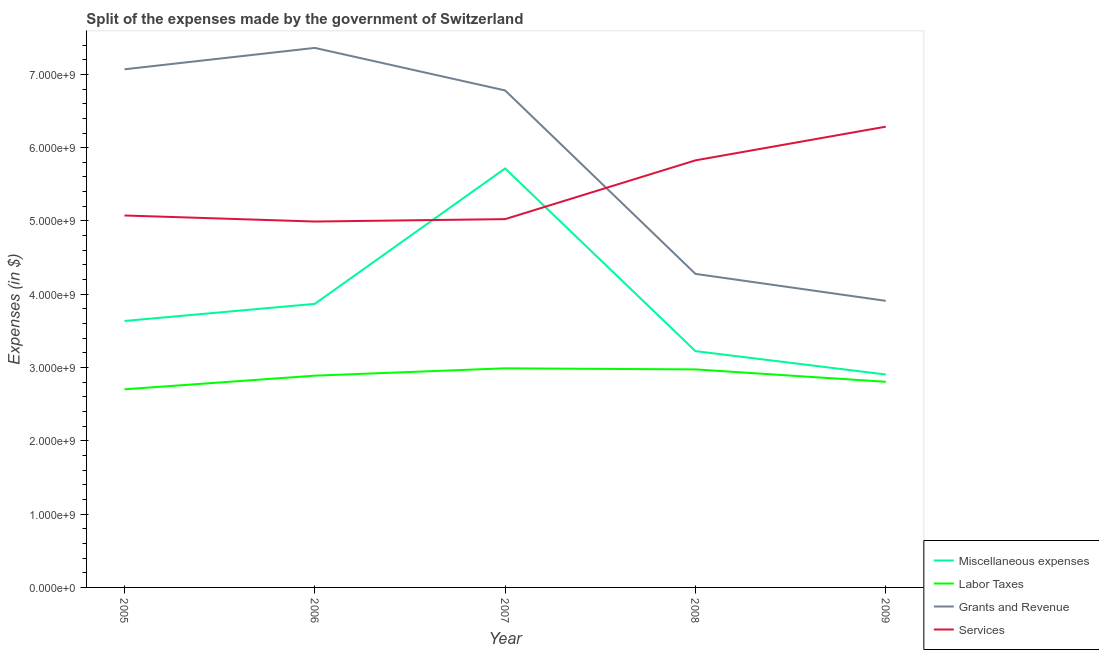Is the number of lines equal to the number of legend labels?
Provide a succinct answer. Yes. What is the amount spent on grants and revenue in 2005?
Provide a succinct answer. 7.07e+09. Across all years, what is the maximum amount spent on grants and revenue?
Your response must be concise. 7.36e+09. Across all years, what is the minimum amount spent on labor taxes?
Your answer should be compact. 2.70e+09. What is the total amount spent on services in the graph?
Provide a short and direct response. 2.72e+1. What is the difference between the amount spent on services in 2005 and that in 2007?
Provide a short and direct response. 4.97e+07. What is the difference between the amount spent on miscellaneous expenses in 2009 and the amount spent on services in 2006?
Ensure brevity in your answer.  -2.09e+09. What is the average amount spent on labor taxes per year?
Your answer should be compact. 2.87e+09. In the year 2006, what is the difference between the amount spent on services and amount spent on miscellaneous expenses?
Your response must be concise. 1.12e+09. In how many years, is the amount spent on miscellaneous expenses greater than 5000000000 $?
Offer a terse response. 1. What is the ratio of the amount spent on labor taxes in 2007 to that in 2009?
Keep it short and to the point. 1.07. Is the amount spent on services in 2008 less than that in 2009?
Ensure brevity in your answer.  Yes. What is the difference between the highest and the second highest amount spent on miscellaneous expenses?
Offer a very short reply. 1.85e+09. What is the difference between the highest and the lowest amount spent on miscellaneous expenses?
Provide a succinct answer. 2.81e+09. Is it the case that in every year, the sum of the amount spent on grants and revenue and amount spent on services is greater than the sum of amount spent on miscellaneous expenses and amount spent on labor taxes?
Your response must be concise. Yes. Is it the case that in every year, the sum of the amount spent on miscellaneous expenses and amount spent on labor taxes is greater than the amount spent on grants and revenue?
Offer a very short reply. No. Does the amount spent on labor taxes monotonically increase over the years?
Your answer should be compact. No. Where does the legend appear in the graph?
Provide a succinct answer. Bottom right. How many legend labels are there?
Provide a succinct answer. 4. What is the title of the graph?
Keep it short and to the point. Split of the expenses made by the government of Switzerland. Does "Subsidies and Transfers" appear as one of the legend labels in the graph?
Offer a terse response. No. What is the label or title of the Y-axis?
Your response must be concise. Expenses (in $). What is the Expenses (in $) of Miscellaneous expenses in 2005?
Give a very brief answer. 3.64e+09. What is the Expenses (in $) in Labor Taxes in 2005?
Your response must be concise. 2.70e+09. What is the Expenses (in $) of Grants and Revenue in 2005?
Your answer should be very brief. 7.07e+09. What is the Expenses (in $) in Services in 2005?
Make the answer very short. 5.07e+09. What is the Expenses (in $) of Miscellaneous expenses in 2006?
Give a very brief answer. 3.87e+09. What is the Expenses (in $) of Labor Taxes in 2006?
Offer a terse response. 2.89e+09. What is the Expenses (in $) of Grants and Revenue in 2006?
Give a very brief answer. 7.36e+09. What is the Expenses (in $) of Services in 2006?
Provide a short and direct response. 4.99e+09. What is the Expenses (in $) in Miscellaneous expenses in 2007?
Keep it short and to the point. 5.72e+09. What is the Expenses (in $) in Labor Taxes in 2007?
Make the answer very short. 2.99e+09. What is the Expenses (in $) of Grants and Revenue in 2007?
Make the answer very short. 6.78e+09. What is the Expenses (in $) in Services in 2007?
Make the answer very short. 5.03e+09. What is the Expenses (in $) of Miscellaneous expenses in 2008?
Provide a succinct answer. 3.22e+09. What is the Expenses (in $) of Labor Taxes in 2008?
Your response must be concise. 2.97e+09. What is the Expenses (in $) in Grants and Revenue in 2008?
Your response must be concise. 4.28e+09. What is the Expenses (in $) in Services in 2008?
Offer a very short reply. 5.83e+09. What is the Expenses (in $) of Miscellaneous expenses in 2009?
Provide a short and direct response. 2.91e+09. What is the Expenses (in $) of Labor Taxes in 2009?
Ensure brevity in your answer.  2.81e+09. What is the Expenses (in $) of Grants and Revenue in 2009?
Ensure brevity in your answer.  3.91e+09. What is the Expenses (in $) in Services in 2009?
Provide a succinct answer. 6.29e+09. Across all years, what is the maximum Expenses (in $) of Miscellaneous expenses?
Ensure brevity in your answer.  5.72e+09. Across all years, what is the maximum Expenses (in $) of Labor Taxes?
Your answer should be very brief. 2.99e+09. Across all years, what is the maximum Expenses (in $) of Grants and Revenue?
Ensure brevity in your answer.  7.36e+09. Across all years, what is the maximum Expenses (in $) in Services?
Ensure brevity in your answer.  6.29e+09. Across all years, what is the minimum Expenses (in $) in Miscellaneous expenses?
Offer a very short reply. 2.91e+09. Across all years, what is the minimum Expenses (in $) in Labor Taxes?
Ensure brevity in your answer.  2.70e+09. Across all years, what is the minimum Expenses (in $) in Grants and Revenue?
Provide a succinct answer. 3.91e+09. Across all years, what is the minimum Expenses (in $) of Services?
Offer a terse response. 4.99e+09. What is the total Expenses (in $) in Miscellaneous expenses in the graph?
Your response must be concise. 1.94e+1. What is the total Expenses (in $) of Labor Taxes in the graph?
Make the answer very short. 1.44e+1. What is the total Expenses (in $) of Grants and Revenue in the graph?
Your response must be concise. 2.94e+1. What is the total Expenses (in $) of Services in the graph?
Your response must be concise. 2.72e+1. What is the difference between the Expenses (in $) of Miscellaneous expenses in 2005 and that in 2006?
Keep it short and to the point. -2.34e+08. What is the difference between the Expenses (in $) of Labor Taxes in 2005 and that in 2006?
Provide a short and direct response. -1.86e+08. What is the difference between the Expenses (in $) of Grants and Revenue in 2005 and that in 2006?
Your answer should be compact. -2.92e+08. What is the difference between the Expenses (in $) of Services in 2005 and that in 2006?
Your answer should be compact. 8.26e+07. What is the difference between the Expenses (in $) of Miscellaneous expenses in 2005 and that in 2007?
Your answer should be compact. -2.08e+09. What is the difference between the Expenses (in $) of Labor Taxes in 2005 and that in 2007?
Offer a very short reply. -2.86e+08. What is the difference between the Expenses (in $) in Grants and Revenue in 2005 and that in 2007?
Keep it short and to the point. 2.89e+08. What is the difference between the Expenses (in $) of Services in 2005 and that in 2007?
Provide a succinct answer. 4.97e+07. What is the difference between the Expenses (in $) of Miscellaneous expenses in 2005 and that in 2008?
Provide a succinct answer. 4.12e+08. What is the difference between the Expenses (in $) in Labor Taxes in 2005 and that in 2008?
Your answer should be compact. -2.71e+08. What is the difference between the Expenses (in $) in Grants and Revenue in 2005 and that in 2008?
Make the answer very short. 2.79e+09. What is the difference between the Expenses (in $) of Services in 2005 and that in 2008?
Offer a very short reply. -7.52e+08. What is the difference between the Expenses (in $) of Miscellaneous expenses in 2005 and that in 2009?
Make the answer very short. 7.30e+08. What is the difference between the Expenses (in $) of Labor Taxes in 2005 and that in 2009?
Make the answer very short. -1.02e+08. What is the difference between the Expenses (in $) in Grants and Revenue in 2005 and that in 2009?
Your answer should be compact. 3.16e+09. What is the difference between the Expenses (in $) of Services in 2005 and that in 2009?
Provide a succinct answer. -1.21e+09. What is the difference between the Expenses (in $) of Miscellaneous expenses in 2006 and that in 2007?
Ensure brevity in your answer.  -1.85e+09. What is the difference between the Expenses (in $) in Labor Taxes in 2006 and that in 2007?
Give a very brief answer. -1.00e+08. What is the difference between the Expenses (in $) in Grants and Revenue in 2006 and that in 2007?
Provide a succinct answer. 5.80e+08. What is the difference between the Expenses (in $) of Services in 2006 and that in 2007?
Provide a succinct answer. -3.29e+07. What is the difference between the Expenses (in $) of Miscellaneous expenses in 2006 and that in 2008?
Make the answer very short. 6.45e+08. What is the difference between the Expenses (in $) of Labor Taxes in 2006 and that in 2008?
Make the answer very short. -8.54e+07. What is the difference between the Expenses (in $) of Grants and Revenue in 2006 and that in 2008?
Provide a short and direct response. 3.08e+09. What is the difference between the Expenses (in $) of Services in 2006 and that in 2008?
Your answer should be very brief. -8.35e+08. What is the difference between the Expenses (in $) in Miscellaneous expenses in 2006 and that in 2009?
Make the answer very short. 9.64e+08. What is the difference between the Expenses (in $) of Labor Taxes in 2006 and that in 2009?
Provide a succinct answer. 8.37e+07. What is the difference between the Expenses (in $) of Grants and Revenue in 2006 and that in 2009?
Your answer should be compact. 3.45e+09. What is the difference between the Expenses (in $) of Services in 2006 and that in 2009?
Provide a short and direct response. -1.29e+09. What is the difference between the Expenses (in $) in Miscellaneous expenses in 2007 and that in 2008?
Make the answer very short. 2.49e+09. What is the difference between the Expenses (in $) in Labor Taxes in 2007 and that in 2008?
Keep it short and to the point. 1.49e+07. What is the difference between the Expenses (in $) in Grants and Revenue in 2007 and that in 2008?
Your answer should be very brief. 2.50e+09. What is the difference between the Expenses (in $) in Services in 2007 and that in 2008?
Give a very brief answer. -8.02e+08. What is the difference between the Expenses (in $) of Miscellaneous expenses in 2007 and that in 2009?
Provide a short and direct response. 2.81e+09. What is the difference between the Expenses (in $) in Labor Taxes in 2007 and that in 2009?
Provide a succinct answer. 1.84e+08. What is the difference between the Expenses (in $) in Grants and Revenue in 2007 and that in 2009?
Ensure brevity in your answer.  2.87e+09. What is the difference between the Expenses (in $) of Services in 2007 and that in 2009?
Provide a succinct answer. -1.26e+09. What is the difference between the Expenses (in $) of Miscellaneous expenses in 2008 and that in 2009?
Offer a very short reply. 3.19e+08. What is the difference between the Expenses (in $) of Labor Taxes in 2008 and that in 2009?
Keep it short and to the point. 1.69e+08. What is the difference between the Expenses (in $) in Grants and Revenue in 2008 and that in 2009?
Ensure brevity in your answer.  3.68e+08. What is the difference between the Expenses (in $) in Services in 2008 and that in 2009?
Make the answer very short. -4.60e+08. What is the difference between the Expenses (in $) in Miscellaneous expenses in 2005 and the Expenses (in $) in Labor Taxes in 2006?
Your response must be concise. 7.46e+08. What is the difference between the Expenses (in $) in Miscellaneous expenses in 2005 and the Expenses (in $) in Grants and Revenue in 2006?
Provide a short and direct response. -3.73e+09. What is the difference between the Expenses (in $) of Miscellaneous expenses in 2005 and the Expenses (in $) of Services in 2006?
Your response must be concise. -1.36e+09. What is the difference between the Expenses (in $) of Labor Taxes in 2005 and the Expenses (in $) of Grants and Revenue in 2006?
Your response must be concise. -4.66e+09. What is the difference between the Expenses (in $) of Labor Taxes in 2005 and the Expenses (in $) of Services in 2006?
Give a very brief answer. -2.29e+09. What is the difference between the Expenses (in $) in Grants and Revenue in 2005 and the Expenses (in $) in Services in 2006?
Keep it short and to the point. 2.08e+09. What is the difference between the Expenses (in $) in Miscellaneous expenses in 2005 and the Expenses (in $) in Labor Taxes in 2007?
Offer a terse response. 6.46e+08. What is the difference between the Expenses (in $) of Miscellaneous expenses in 2005 and the Expenses (in $) of Grants and Revenue in 2007?
Your answer should be compact. -3.15e+09. What is the difference between the Expenses (in $) in Miscellaneous expenses in 2005 and the Expenses (in $) in Services in 2007?
Ensure brevity in your answer.  -1.39e+09. What is the difference between the Expenses (in $) of Labor Taxes in 2005 and the Expenses (in $) of Grants and Revenue in 2007?
Make the answer very short. -4.08e+09. What is the difference between the Expenses (in $) in Labor Taxes in 2005 and the Expenses (in $) in Services in 2007?
Your answer should be compact. -2.32e+09. What is the difference between the Expenses (in $) in Grants and Revenue in 2005 and the Expenses (in $) in Services in 2007?
Offer a terse response. 2.04e+09. What is the difference between the Expenses (in $) in Miscellaneous expenses in 2005 and the Expenses (in $) in Labor Taxes in 2008?
Your answer should be compact. 6.61e+08. What is the difference between the Expenses (in $) in Miscellaneous expenses in 2005 and the Expenses (in $) in Grants and Revenue in 2008?
Provide a succinct answer. -6.43e+08. What is the difference between the Expenses (in $) in Miscellaneous expenses in 2005 and the Expenses (in $) in Services in 2008?
Keep it short and to the point. -2.19e+09. What is the difference between the Expenses (in $) of Labor Taxes in 2005 and the Expenses (in $) of Grants and Revenue in 2008?
Keep it short and to the point. -1.57e+09. What is the difference between the Expenses (in $) in Labor Taxes in 2005 and the Expenses (in $) in Services in 2008?
Your answer should be very brief. -3.12e+09. What is the difference between the Expenses (in $) in Grants and Revenue in 2005 and the Expenses (in $) in Services in 2008?
Provide a short and direct response. 1.24e+09. What is the difference between the Expenses (in $) of Miscellaneous expenses in 2005 and the Expenses (in $) of Labor Taxes in 2009?
Provide a succinct answer. 8.30e+08. What is the difference between the Expenses (in $) of Miscellaneous expenses in 2005 and the Expenses (in $) of Grants and Revenue in 2009?
Your answer should be compact. -2.75e+08. What is the difference between the Expenses (in $) of Miscellaneous expenses in 2005 and the Expenses (in $) of Services in 2009?
Offer a terse response. -2.65e+09. What is the difference between the Expenses (in $) in Labor Taxes in 2005 and the Expenses (in $) in Grants and Revenue in 2009?
Give a very brief answer. -1.21e+09. What is the difference between the Expenses (in $) of Labor Taxes in 2005 and the Expenses (in $) of Services in 2009?
Your answer should be very brief. -3.58e+09. What is the difference between the Expenses (in $) of Grants and Revenue in 2005 and the Expenses (in $) of Services in 2009?
Your answer should be very brief. 7.83e+08. What is the difference between the Expenses (in $) of Miscellaneous expenses in 2006 and the Expenses (in $) of Labor Taxes in 2007?
Make the answer very short. 8.80e+08. What is the difference between the Expenses (in $) of Miscellaneous expenses in 2006 and the Expenses (in $) of Grants and Revenue in 2007?
Keep it short and to the point. -2.91e+09. What is the difference between the Expenses (in $) of Miscellaneous expenses in 2006 and the Expenses (in $) of Services in 2007?
Your answer should be compact. -1.16e+09. What is the difference between the Expenses (in $) of Labor Taxes in 2006 and the Expenses (in $) of Grants and Revenue in 2007?
Keep it short and to the point. -3.89e+09. What is the difference between the Expenses (in $) in Labor Taxes in 2006 and the Expenses (in $) in Services in 2007?
Your answer should be compact. -2.14e+09. What is the difference between the Expenses (in $) of Grants and Revenue in 2006 and the Expenses (in $) of Services in 2007?
Make the answer very short. 2.34e+09. What is the difference between the Expenses (in $) of Miscellaneous expenses in 2006 and the Expenses (in $) of Labor Taxes in 2008?
Your response must be concise. 8.94e+08. What is the difference between the Expenses (in $) of Miscellaneous expenses in 2006 and the Expenses (in $) of Grants and Revenue in 2008?
Your response must be concise. -4.09e+08. What is the difference between the Expenses (in $) in Miscellaneous expenses in 2006 and the Expenses (in $) in Services in 2008?
Your answer should be compact. -1.96e+09. What is the difference between the Expenses (in $) in Labor Taxes in 2006 and the Expenses (in $) in Grants and Revenue in 2008?
Ensure brevity in your answer.  -1.39e+09. What is the difference between the Expenses (in $) of Labor Taxes in 2006 and the Expenses (in $) of Services in 2008?
Your response must be concise. -2.94e+09. What is the difference between the Expenses (in $) in Grants and Revenue in 2006 and the Expenses (in $) in Services in 2008?
Your response must be concise. 1.53e+09. What is the difference between the Expenses (in $) of Miscellaneous expenses in 2006 and the Expenses (in $) of Labor Taxes in 2009?
Offer a very short reply. 1.06e+09. What is the difference between the Expenses (in $) in Miscellaneous expenses in 2006 and the Expenses (in $) in Grants and Revenue in 2009?
Provide a short and direct response. -4.11e+07. What is the difference between the Expenses (in $) of Miscellaneous expenses in 2006 and the Expenses (in $) of Services in 2009?
Keep it short and to the point. -2.42e+09. What is the difference between the Expenses (in $) of Labor Taxes in 2006 and the Expenses (in $) of Grants and Revenue in 2009?
Provide a short and direct response. -1.02e+09. What is the difference between the Expenses (in $) of Labor Taxes in 2006 and the Expenses (in $) of Services in 2009?
Your answer should be very brief. -3.40e+09. What is the difference between the Expenses (in $) of Grants and Revenue in 2006 and the Expenses (in $) of Services in 2009?
Provide a succinct answer. 1.07e+09. What is the difference between the Expenses (in $) of Miscellaneous expenses in 2007 and the Expenses (in $) of Labor Taxes in 2008?
Offer a terse response. 2.74e+09. What is the difference between the Expenses (in $) in Miscellaneous expenses in 2007 and the Expenses (in $) in Grants and Revenue in 2008?
Your response must be concise. 1.44e+09. What is the difference between the Expenses (in $) of Miscellaneous expenses in 2007 and the Expenses (in $) of Services in 2008?
Your response must be concise. -1.10e+08. What is the difference between the Expenses (in $) in Labor Taxes in 2007 and the Expenses (in $) in Grants and Revenue in 2008?
Your answer should be compact. -1.29e+09. What is the difference between the Expenses (in $) of Labor Taxes in 2007 and the Expenses (in $) of Services in 2008?
Give a very brief answer. -2.84e+09. What is the difference between the Expenses (in $) of Grants and Revenue in 2007 and the Expenses (in $) of Services in 2008?
Keep it short and to the point. 9.54e+08. What is the difference between the Expenses (in $) in Miscellaneous expenses in 2007 and the Expenses (in $) in Labor Taxes in 2009?
Provide a succinct answer. 2.91e+09. What is the difference between the Expenses (in $) of Miscellaneous expenses in 2007 and the Expenses (in $) of Grants and Revenue in 2009?
Keep it short and to the point. 1.81e+09. What is the difference between the Expenses (in $) in Miscellaneous expenses in 2007 and the Expenses (in $) in Services in 2009?
Your answer should be very brief. -5.70e+08. What is the difference between the Expenses (in $) of Labor Taxes in 2007 and the Expenses (in $) of Grants and Revenue in 2009?
Ensure brevity in your answer.  -9.21e+08. What is the difference between the Expenses (in $) of Labor Taxes in 2007 and the Expenses (in $) of Services in 2009?
Your answer should be compact. -3.30e+09. What is the difference between the Expenses (in $) in Grants and Revenue in 2007 and the Expenses (in $) in Services in 2009?
Make the answer very short. 4.94e+08. What is the difference between the Expenses (in $) of Miscellaneous expenses in 2008 and the Expenses (in $) of Labor Taxes in 2009?
Make the answer very short. 4.18e+08. What is the difference between the Expenses (in $) of Miscellaneous expenses in 2008 and the Expenses (in $) of Grants and Revenue in 2009?
Keep it short and to the point. -6.86e+08. What is the difference between the Expenses (in $) of Miscellaneous expenses in 2008 and the Expenses (in $) of Services in 2009?
Make the answer very short. -3.06e+09. What is the difference between the Expenses (in $) of Labor Taxes in 2008 and the Expenses (in $) of Grants and Revenue in 2009?
Your answer should be very brief. -9.36e+08. What is the difference between the Expenses (in $) of Labor Taxes in 2008 and the Expenses (in $) of Services in 2009?
Provide a short and direct response. -3.31e+09. What is the difference between the Expenses (in $) in Grants and Revenue in 2008 and the Expenses (in $) in Services in 2009?
Provide a short and direct response. -2.01e+09. What is the average Expenses (in $) of Miscellaneous expenses per year?
Make the answer very short. 3.87e+09. What is the average Expenses (in $) of Labor Taxes per year?
Provide a short and direct response. 2.87e+09. What is the average Expenses (in $) of Grants and Revenue per year?
Your answer should be very brief. 5.88e+09. What is the average Expenses (in $) of Services per year?
Offer a very short reply. 5.44e+09. In the year 2005, what is the difference between the Expenses (in $) of Miscellaneous expenses and Expenses (in $) of Labor Taxes?
Provide a short and direct response. 9.32e+08. In the year 2005, what is the difference between the Expenses (in $) of Miscellaneous expenses and Expenses (in $) of Grants and Revenue?
Your answer should be very brief. -3.43e+09. In the year 2005, what is the difference between the Expenses (in $) of Miscellaneous expenses and Expenses (in $) of Services?
Make the answer very short. -1.44e+09. In the year 2005, what is the difference between the Expenses (in $) in Labor Taxes and Expenses (in $) in Grants and Revenue?
Keep it short and to the point. -4.37e+09. In the year 2005, what is the difference between the Expenses (in $) of Labor Taxes and Expenses (in $) of Services?
Provide a short and direct response. -2.37e+09. In the year 2005, what is the difference between the Expenses (in $) in Grants and Revenue and Expenses (in $) in Services?
Offer a terse response. 1.99e+09. In the year 2006, what is the difference between the Expenses (in $) in Miscellaneous expenses and Expenses (in $) in Labor Taxes?
Provide a short and direct response. 9.80e+08. In the year 2006, what is the difference between the Expenses (in $) in Miscellaneous expenses and Expenses (in $) in Grants and Revenue?
Your response must be concise. -3.49e+09. In the year 2006, what is the difference between the Expenses (in $) of Miscellaneous expenses and Expenses (in $) of Services?
Offer a very short reply. -1.12e+09. In the year 2006, what is the difference between the Expenses (in $) of Labor Taxes and Expenses (in $) of Grants and Revenue?
Your answer should be compact. -4.47e+09. In the year 2006, what is the difference between the Expenses (in $) of Labor Taxes and Expenses (in $) of Services?
Your answer should be very brief. -2.10e+09. In the year 2006, what is the difference between the Expenses (in $) of Grants and Revenue and Expenses (in $) of Services?
Make the answer very short. 2.37e+09. In the year 2007, what is the difference between the Expenses (in $) in Miscellaneous expenses and Expenses (in $) in Labor Taxes?
Keep it short and to the point. 2.73e+09. In the year 2007, what is the difference between the Expenses (in $) in Miscellaneous expenses and Expenses (in $) in Grants and Revenue?
Give a very brief answer. -1.06e+09. In the year 2007, what is the difference between the Expenses (in $) of Miscellaneous expenses and Expenses (in $) of Services?
Ensure brevity in your answer.  6.92e+08. In the year 2007, what is the difference between the Expenses (in $) in Labor Taxes and Expenses (in $) in Grants and Revenue?
Keep it short and to the point. -3.79e+09. In the year 2007, what is the difference between the Expenses (in $) of Labor Taxes and Expenses (in $) of Services?
Keep it short and to the point. -2.04e+09. In the year 2007, what is the difference between the Expenses (in $) of Grants and Revenue and Expenses (in $) of Services?
Your response must be concise. 1.76e+09. In the year 2008, what is the difference between the Expenses (in $) of Miscellaneous expenses and Expenses (in $) of Labor Taxes?
Your response must be concise. 2.49e+08. In the year 2008, what is the difference between the Expenses (in $) in Miscellaneous expenses and Expenses (in $) in Grants and Revenue?
Offer a terse response. -1.05e+09. In the year 2008, what is the difference between the Expenses (in $) of Miscellaneous expenses and Expenses (in $) of Services?
Offer a very short reply. -2.60e+09. In the year 2008, what is the difference between the Expenses (in $) of Labor Taxes and Expenses (in $) of Grants and Revenue?
Provide a short and direct response. -1.30e+09. In the year 2008, what is the difference between the Expenses (in $) of Labor Taxes and Expenses (in $) of Services?
Provide a short and direct response. -2.85e+09. In the year 2008, what is the difference between the Expenses (in $) of Grants and Revenue and Expenses (in $) of Services?
Offer a very short reply. -1.55e+09. In the year 2009, what is the difference between the Expenses (in $) in Miscellaneous expenses and Expenses (in $) in Labor Taxes?
Provide a succinct answer. 9.96e+07. In the year 2009, what is the difference between the Expenses (in $) of Miscellaneous expenses and Expenses (in $) of Grants and Revenue?
Provide a short and direct response. -1.01e+09. In the year 2009, what is the difference between the Expenses (in $) in Miscellaneous expenses and Expenses (in $) in Services?
Keep it short and to the point. -3.38e+09. In the year 2009, what is the difference between the Expenses (in $) in Labor Taxes and Expenses (in $) in Grants and Revenue?
Provide a succinct answer. -1.10e+09. In the year 2009, what is the difference between the Expenses (in $) in Labor Taxes and Expenses (in $) in Services?
Give a very brief answer. -3.48e+09. In the year 2009, what is the difference between the Expenses (in $) in Grants and Revenue and Expenses (in $) in Services?
Your answer should be compact. -2.38e+09. What is the ratio of the Expenses (in $) of Miscellaneous expenses in 2005 to that in 2006?
Your response must be concise. 0.94. What is the ratio of the Expenses (in $) of Labor Taxes in 2005 to that in 2006?
Your answer should be very brief. 0.94. What is the ratio of the Expenses (in $) of Grants and Revenue in 2005 to that in 2006?
Keep it short and to the point. 0.96. What is the ratio of the Expenses (in $) of Services in 2005 to that in 2006?
Provide a succinct answer. 1.02. What is the ratio of the Expenses (in $) of Miscellaneous expenses in 2005 to that in 2007?
Keep it short and to the point. 0.64. What is the ratio of the Expenses (in $) of Labor Taxes in 2005 to that in 2007?
Your answer should be very brief. 0.9. What is the ratio of the Expenses (in $) in Grants and Revenue in 2005 to that in 2007?
Ensure brevity in your answer.  1.04. What is the ratio of the Expenses (in $) of Services in 2005 to that in 2007?
Provide a short and direct response. 1.01. What is the ratio of the Expenses (in $) in Miscellaneous expenses in 2005 to that in 2008?
Make the answer very short. 1.13. What is the ratio of the Expenses (in $) in Labor Taxes in 2005 to that in 2008?
Ensure brevity in your answer.  0.91. What is the ratio of the Expenses (in $) of Grants and Revenue in 2005 to that in 2008?
Offer a terse response. 1.65. What is the ratio of the Expenses (in $) of Services in 2005 to that in 2008?
Make the answer very short. 0.87. What is the ratio of the Expenses (in $) in Miscellaneous expenses in 2005 to that in 2009?
Keep it short and to the point. 1.25. What is the ratio of the Expenses (in $) of Labor Taxes in 2005 to that in 2009?
Your answer should be compact. 0.96. What is the ratio of the Expenses (in $) of Grants and Revenue in 2005 to that in 2009?
Ensure brevity in your answer.  1.81. What is the ratio of the Expenses (in $) of Services in 2005 to that in 2009?
Keep it short and to the point. 0.81. What is the ratio of the Expenses (in $) in Miscellaneous expenses in 2006 to that in 2007?
Ensure brevity in your answer.  0.68. What is the ratio of the Expenses (in $) of Labor Taxes in 2006 to that in 2007?
Your answer should be compact. 0.97. What is the ratio of the Expenses (in $) in Grants and Revenue in 2006 to that in 2007?
Your answer should be compact. 1.09. What is the ratio of the Expenses (in $) in Miscellaneous expenses in 2006 to that in 2008?
Provide a short and direct response. 1.2. What is the ratio of the Expenses (in $) in Labor Taxes in 2006 to that in 2008?
Provide a succinct answer. 0.97. What is the ratio of the Expenses (in $) of Grants and Revenue in 2006 to that in 2008?
Provide a succinct answer. 1.72. What is the ratio of the Expenses (in $) of Services in 2006 to that in 2008?
Keep it short and to the point. 0.86. What is the ratio of the Expenses (in $) in Miscellaneous expenses in 2006 to that in 2009?
Keep it short and to the point. 1.33. What is the ratio of the Expenses (in $) in Labor Taxes in 2006 to that in 2009?
Your answer should be compact. 1.03. What is the ratio of the Expenses (in $) in Grants and Revenue in 2006 to that in 2009?
Provide a short and direct response. 1.88. What is the ratio of the Expenses (in $) of Services in 2006 to that in 2009?
Your answer should be very brief. 0.79. What is the ratio of the Expenses (in $) of Miscellaneous expenses in 2007 to that in 2008?
Keep it short and to the point. 1.77. What is the ratio of the Expenses (in $) of Grants and Revenue in 2007 to that in 2008?
Offer a very short reply. 1.58. What is the ratio of the Expenses (in $) of Services in 2007 to that in 2008?
Offer a terse response. 0.86. What is the ratio of the Expenses (in $) in Miscellaneous expenses in 2007 to that in 2009?
Your response must be concise. 1.97. What is the ratio of the Expenses (in $) of Labor Taxes in 2007 to that in 2009?
Give a very brief answer. 1.07. What is the ratio of the Expenses (in $) in Grants and Revenue in 2007 to that in 2009?
Your response must be concise. 1.73. What is the ratio of the Expenses (in $) of Services in 2007 to that in 2009?
Make the answer very short. 0.8. What is the ratio of the Expenses (in $) in Miscellaneous expenses in 2008 to that in 2009?
Offer a terse response. 1.11. What is the ratio of the Expenses (in $) of Labor Taxes in 2008 to that in 2009?
Ensure brevity in your answer.  1.06. What is the ratio of the Expenses (in $) in Grants and Revenue in 2008 to that in 2009?
Your answer should be very brief. 1.09. What is the ratio of the Expenses (in $) of Services in 2008 to that in 2009?
Keep it short and to the point. 0.93. What is the difference between the highest and the second highest Expenses (in $) of Miscellaneous expenses?
Offer a terse response. 1.85e+09. What is the difference between the highest and the second highest Expenses (in $) in Labor Taxes?
Provide a short and direct response. 1.49e+07. What is the difference between the highest and the second highest Expenses (in $) of Grants and Revenue?
Your response must be concise. 2.92e+08. What is the difference between the highest and the second highest Expenses (in $) in Services?
Provide a short and direct response. 4.60e+08. What is the difference between the highest and the lowest Expenses (in $) of Miscellaneous expenses?
Provide a short and direct response. 2.81e+09. What is the difference between the highest and the lowest Expenses (in $) in Labor Taxes?
Ensure brevity in your answer.  2.86e+08. What is the difference between the highest and the lowest Expenses (in $) of Grants and Revenue?
Your response must be concise. 3.45e+09. What is the difference between the highest and the lowest Expenses (in $) in Services?
Give a very brief answer. 1.29e+09. 